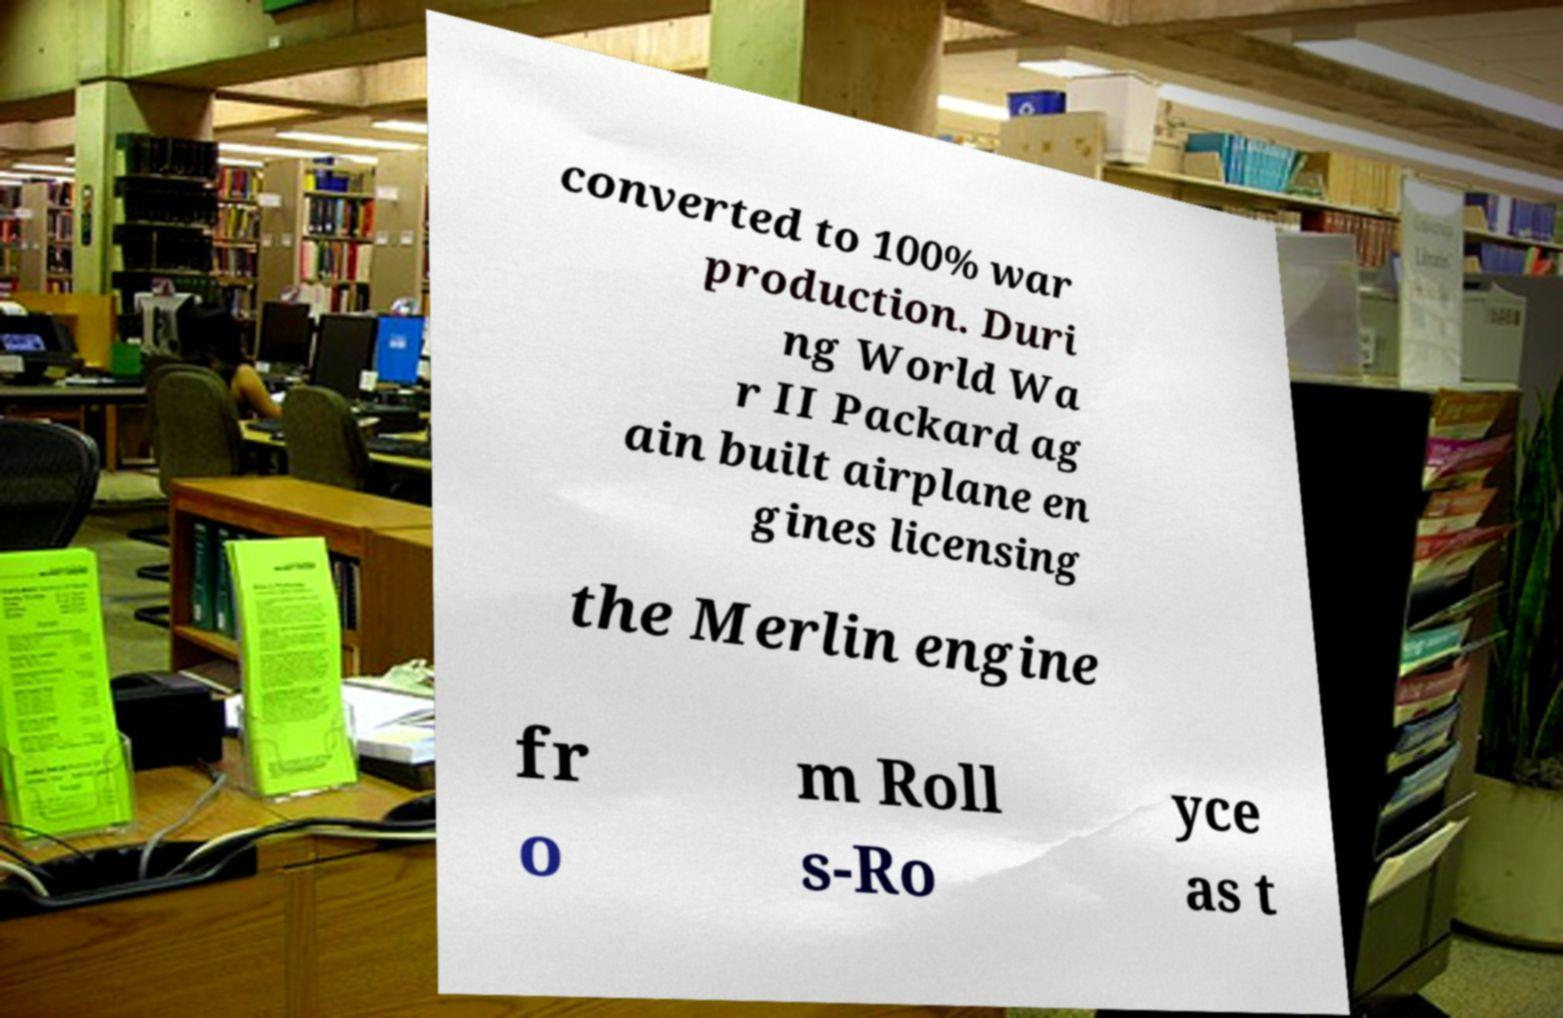What messages or text are displayed in this image? I need them in a readable, typed format. converted to 100% war production. Duri ng World Wa r II Packard ag ain built airplane en gines licensing the Merlin engine fr o m Roll s-Ro yce as t 